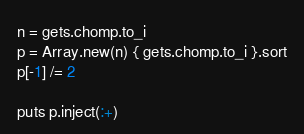<code> <loc_0><loc_0><loc_500><loc_500><_Ruby_>n = gets.chomp.to_i
p = Array.new(n) { gets.chomp.to_i }.sort
p[-1] /= 2

puts p.inject(:+)
</code> 